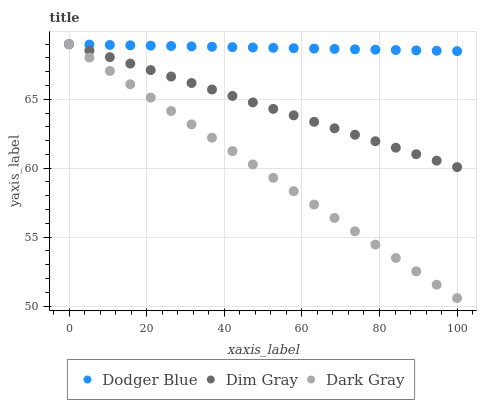Does Dark Gray have the minimum area under the curve?
Answer yes or no. Yes. Does Dodger Blue have the maximum area under the curve?
Answer yes or no. Yes. Does Dim Gray have the minimum area under the curve?
Answer yes or no. No. Does Dim Gray have the maximum area under the curve?
Answer yes or no. No. Is Dodger Blue the smoothest?
Answer yes or no. Yes. Is Dim Gray the roughest?
Answer yes or no. Yes. Is Dim Gray the smoothest?
Answer yes or no. No. Is Dodger Blue the roughest?
Answer yes or no. No. Does Dark Gray have the lowest value?
Answer yes or no. Yes. Does Dim Gray have the lowest value?
Answer yes or no. No. Does Dodger Blue have the highest value?
Answer yes or no. Yes. Does Dodger Blue intersect Dim Gray?
Answer yes or no. Yes. Is Dodger Blue less than Dim Gray?
Answer yes or no. No. Is Dodger Blue greater than Dim Gray?
Answer yes or no. No. 